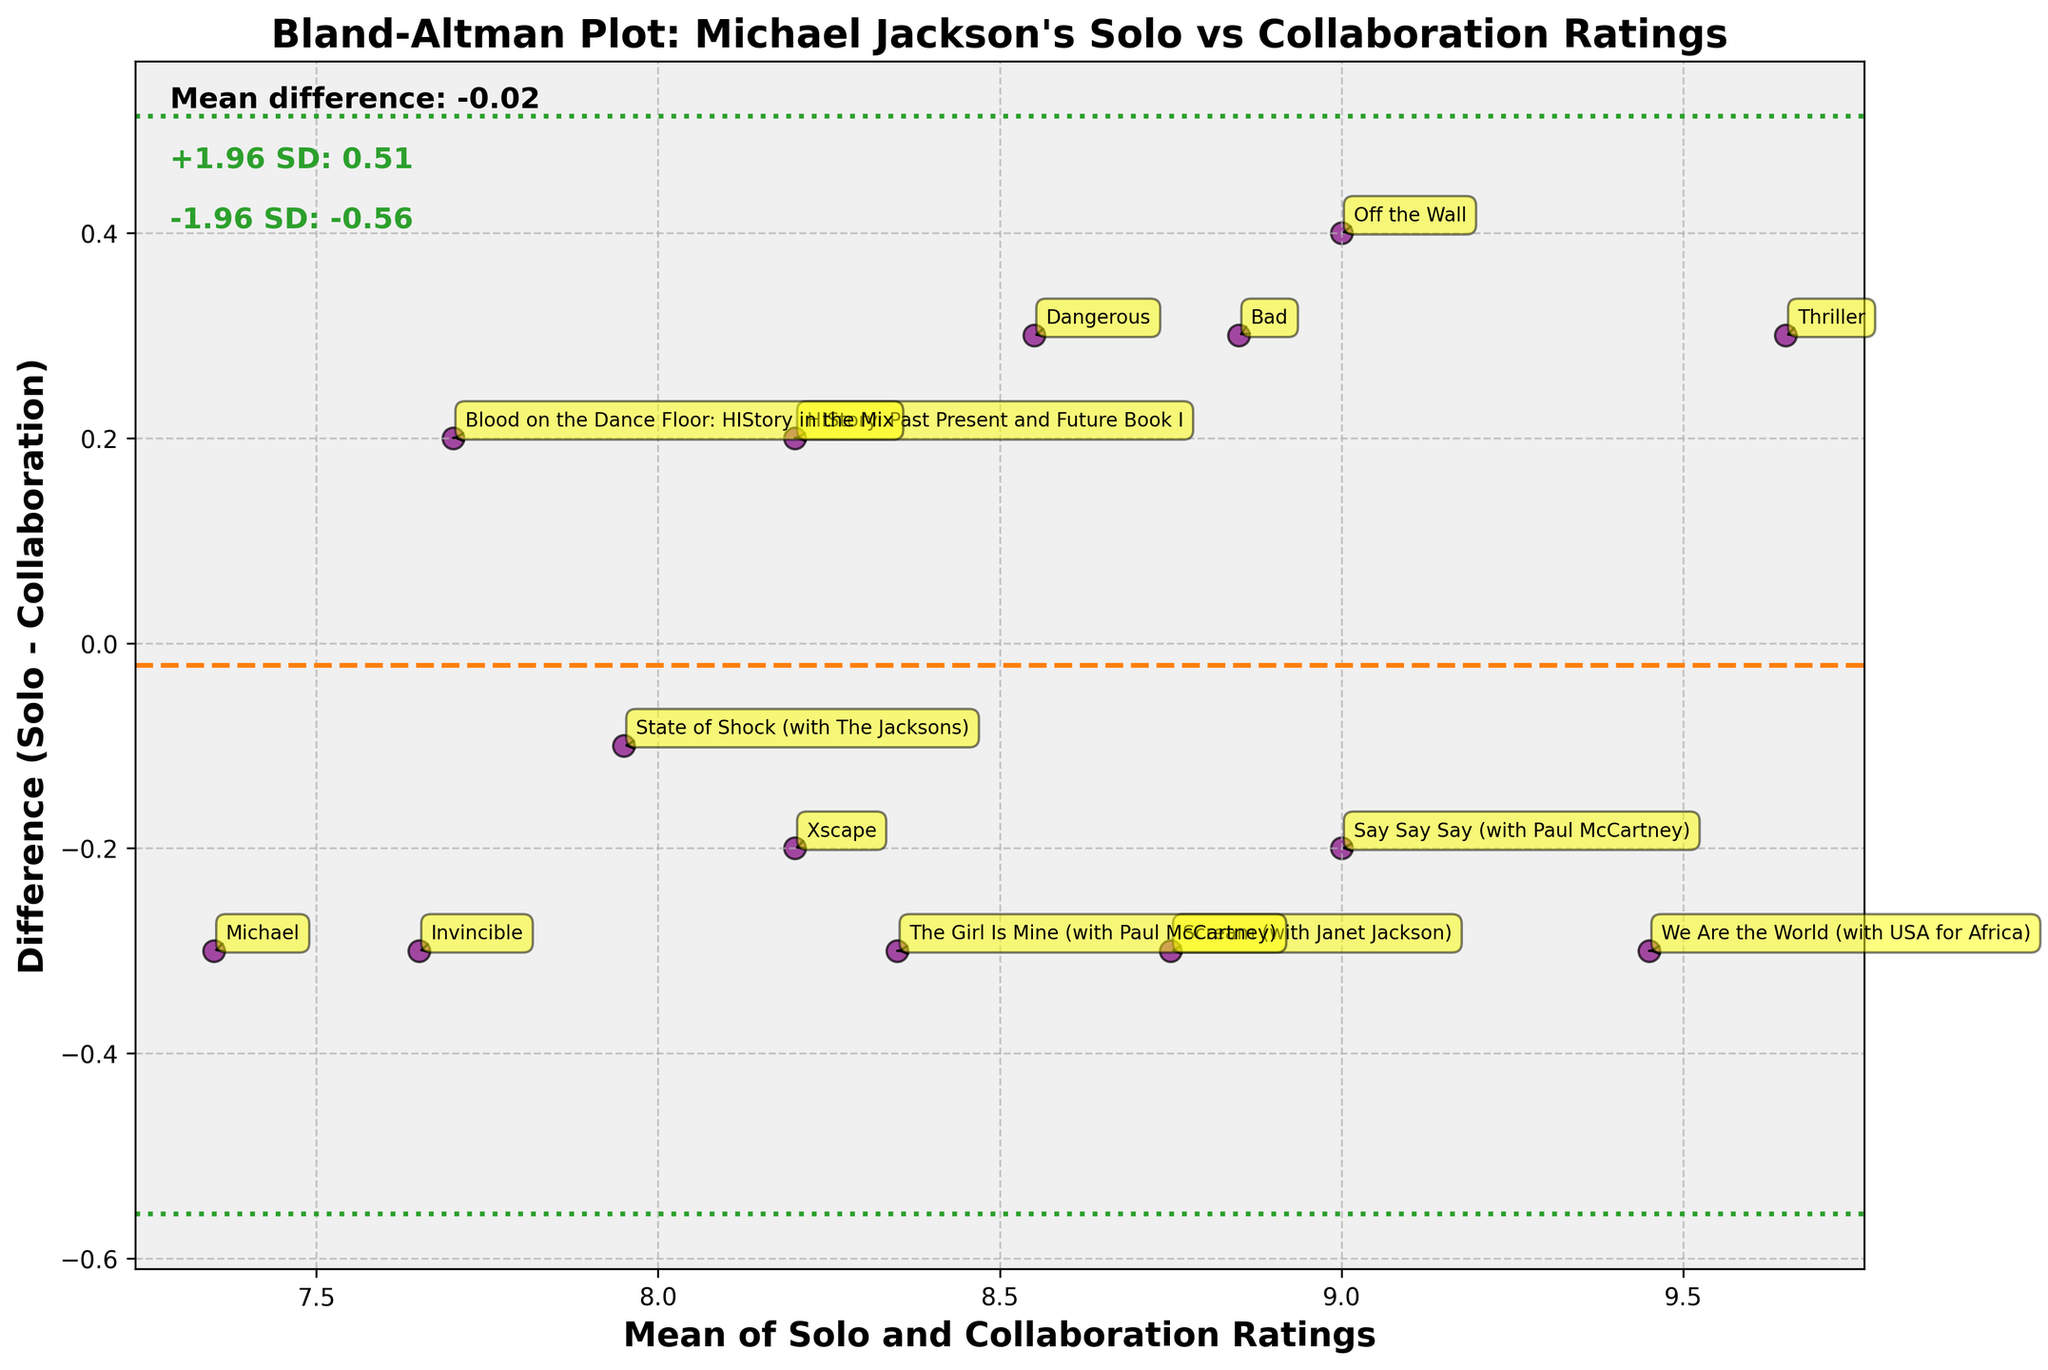What is the title of the Bland-Altman plot? The title of the plot is usually displayed at the top of the figure. It describes the chart's main purpose or the comparison it is displaying.
Answer: Bland-Altman Plot: Michael Jackson's Solo vs Collaboration Ratings Which axis represents the mean of Solo and Collaboration Ratings? The x-axis, typically located at the bottom of the chart, is labeled with what it represents. In this case, it is labeled as "Mean of Solo and Collaboration Ratings".
Answer: x-axis What color are the data points in the Bland-Altman plot? The color of the data points can be observed directly from the figure. The data points in this plot are noted with a specific mention.
Answer: Purple How many albums have a higher solo rating than collaboration rating? By observing whether the data points are above or below the horizontal zero difference line, we can count the number of albums where the solo ratings are higher.
Answer: 6 What is the mean difference between Solo and Collaboration Ratings, and how is it visually represented? The mean difference is a line typically positioned parallel to the x-axis. The plot also contains text annotations with the numerical value of this mean difference.
Answer: -0.16 Which album has the largest positive difference between solo and collaboration ratings? The album with the largest positive difference will appear at the highest point above the zero difference line.
Answer: Invincible What are the upper and lower limits of agreement, and how are they represented in the chart? The upper and lower limits of agreement are represented by dashed lines and specific colors. The plot also includes text annotations stating their values.
Answer: +1.96 SD: 0.34, -1.96 SD: -0.66 Which album has the lowest mean of Solo and Collaboration Ratings? By locating the leftmost point on the x-axis where the mean ratings are plotted, we can identify the corresponding album.
Answer: Michael What range does the x-axis cover in the Bland-Altman plot? The range of the x-axis can be identified by noting the minimum and maximum values observed in the plot.
Answer: 7.35 to 9.45 Compare the ratings for "Thriller" and "Bad". Which album has a higher score on both Solo and Collaboration Ratings? By identifying and comparing the positions of the points for "Thriller" and "Bad" on the plot, we can determine which album has higher ratings in both categories.
Answer: Thriller 